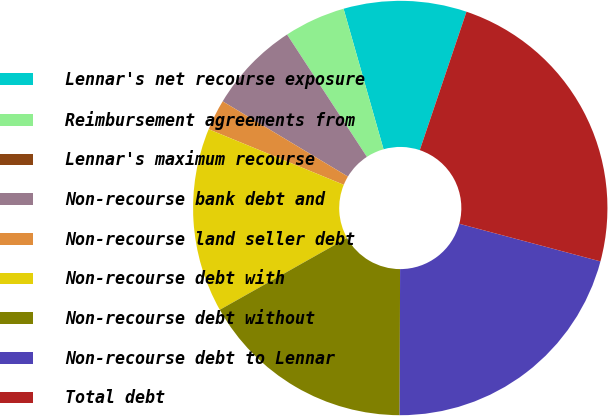<chart> <loc_0><loc_0><loc_500><loc_500><pie_chart><fcel>Lennar's net recourse exposure<fcel>Reimbursement agreements from<fcel>Lennar's maximum recourse<fcel>Non-recourse bank debt and<fcel>Non-recourse land seller debt<fcel>Non-recourse debt with<fcel>Non-recourse debt without<fcel>Non-recourse debt to Lennar<fcel>Total debt<nl><fcel>9.59%<fcel>4.79%<fcel>0.0%<fcel>7.19%<fcel>2.4%<fcel>14.38%<fcel>16.78%<fcel>20.9%<fcel>23.97%<nl></chart> 